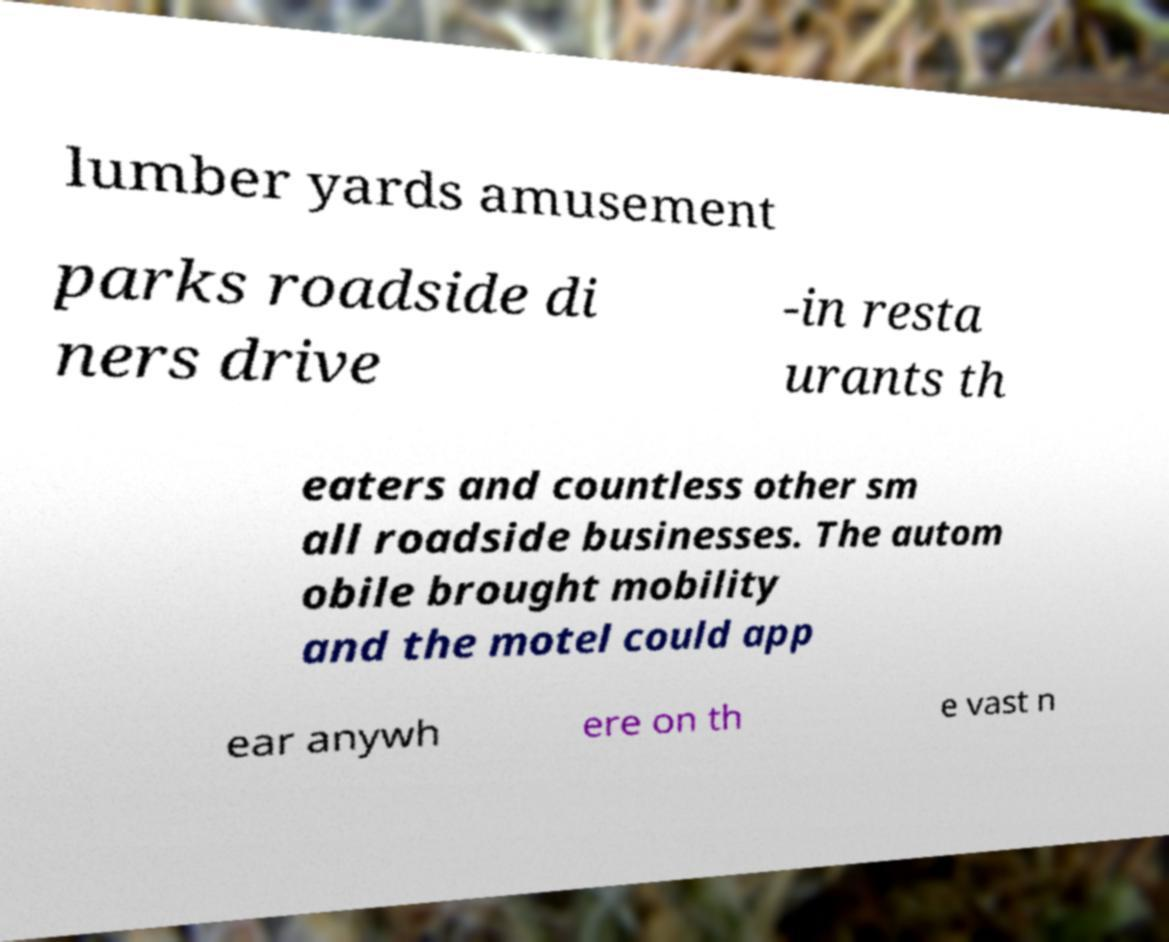For documentation purposes, I need the text within this image transcribed. Could you provide that? lumber yards amusement parks roadside di ners drive -in resta urants th eaters and countless other sm all roadside businesses. The autom obile brought mobility and the motel could app ear anywh ere on th e vast n 